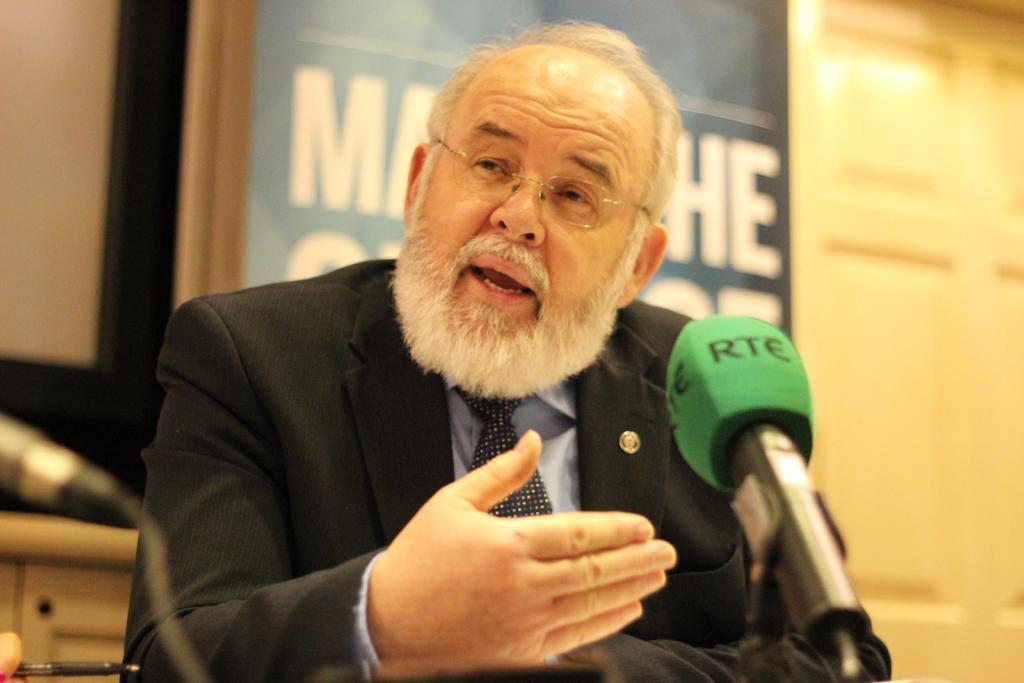Could you give a brief overview of what you see in this image? In this image in the front there is a mic in the center, there is a person speaking in the background there is a board with some text written on it and there is a door and there is an object which is white in colour. 